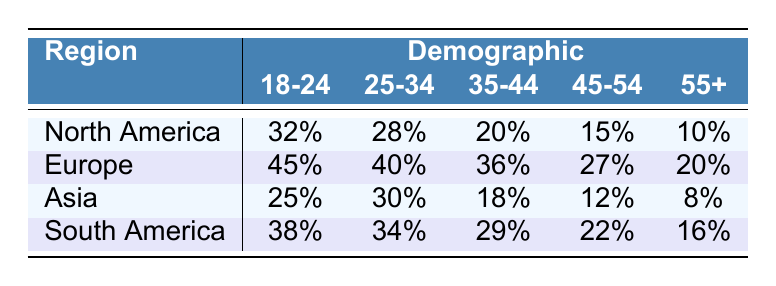What is the participation rate for 18-24 years in Europe? The table lists the participation rate for each demographic in various regions. For the age group 18-24, the participation rate in Europe is shown as 45%.
Answer: 45% Which region has the highest participation rate for the demographic 25-34 years? Reviewing the participation rates for the 25-34 age group across regions, Europe has the highest rate at 40%, compared to 34% in South America, 30% in Asia, and 28% in North America.
Answer: Europe What is the total participation rate for the demographic 35-44 years across all regions? To find the total, we add the participation rates for that age group from each region: North America (20) + Europe (36) + Asia (18) + South America (29) = 103.
Answer: 103 Is the participation rate for 45-54 years higher in South America than in North America? The participation rate for South America is 22%, while North America has a rate of 15%. Since 22% is greater than 15%, the statement is true.
Answer: Yes What is the average participation rate for the demographic 55+ across all regions? We calculate the average by summing the rates for the demographic 55+ from each region: North America (10) + Europe (20) + Asia (8) + South America (16) = 54. We then divide by the number of regions (4): 54 / 4 = 13.5.
Answer: 13.5 Which demographic in Asia has the lowest participation rate? Referring to the table, the participation rates for Asia are: 18-24 years (25%), 25-34 years (30%), 35-44 years (18%), 45-54 years (12%), and 55+ years (8%). The lowest rate is in the 55+ years demographic at 8%.
Answer: 55+ years Does the participation rate for 18-24 years in North America exceed that of Asia? Comparing the rates: North America has 32% and Asia has 25%. Since 32% is greater than 25%, the answer is yes.
Answer: Yes What is the difference in participation rates between the demographic 45-54 years in Europe and South America? The participation rate for 45-54 years in Europe is 27%, and in South America, it is 22%. The difference is calculated as 27 - 22 = 5.
Answer: 5 